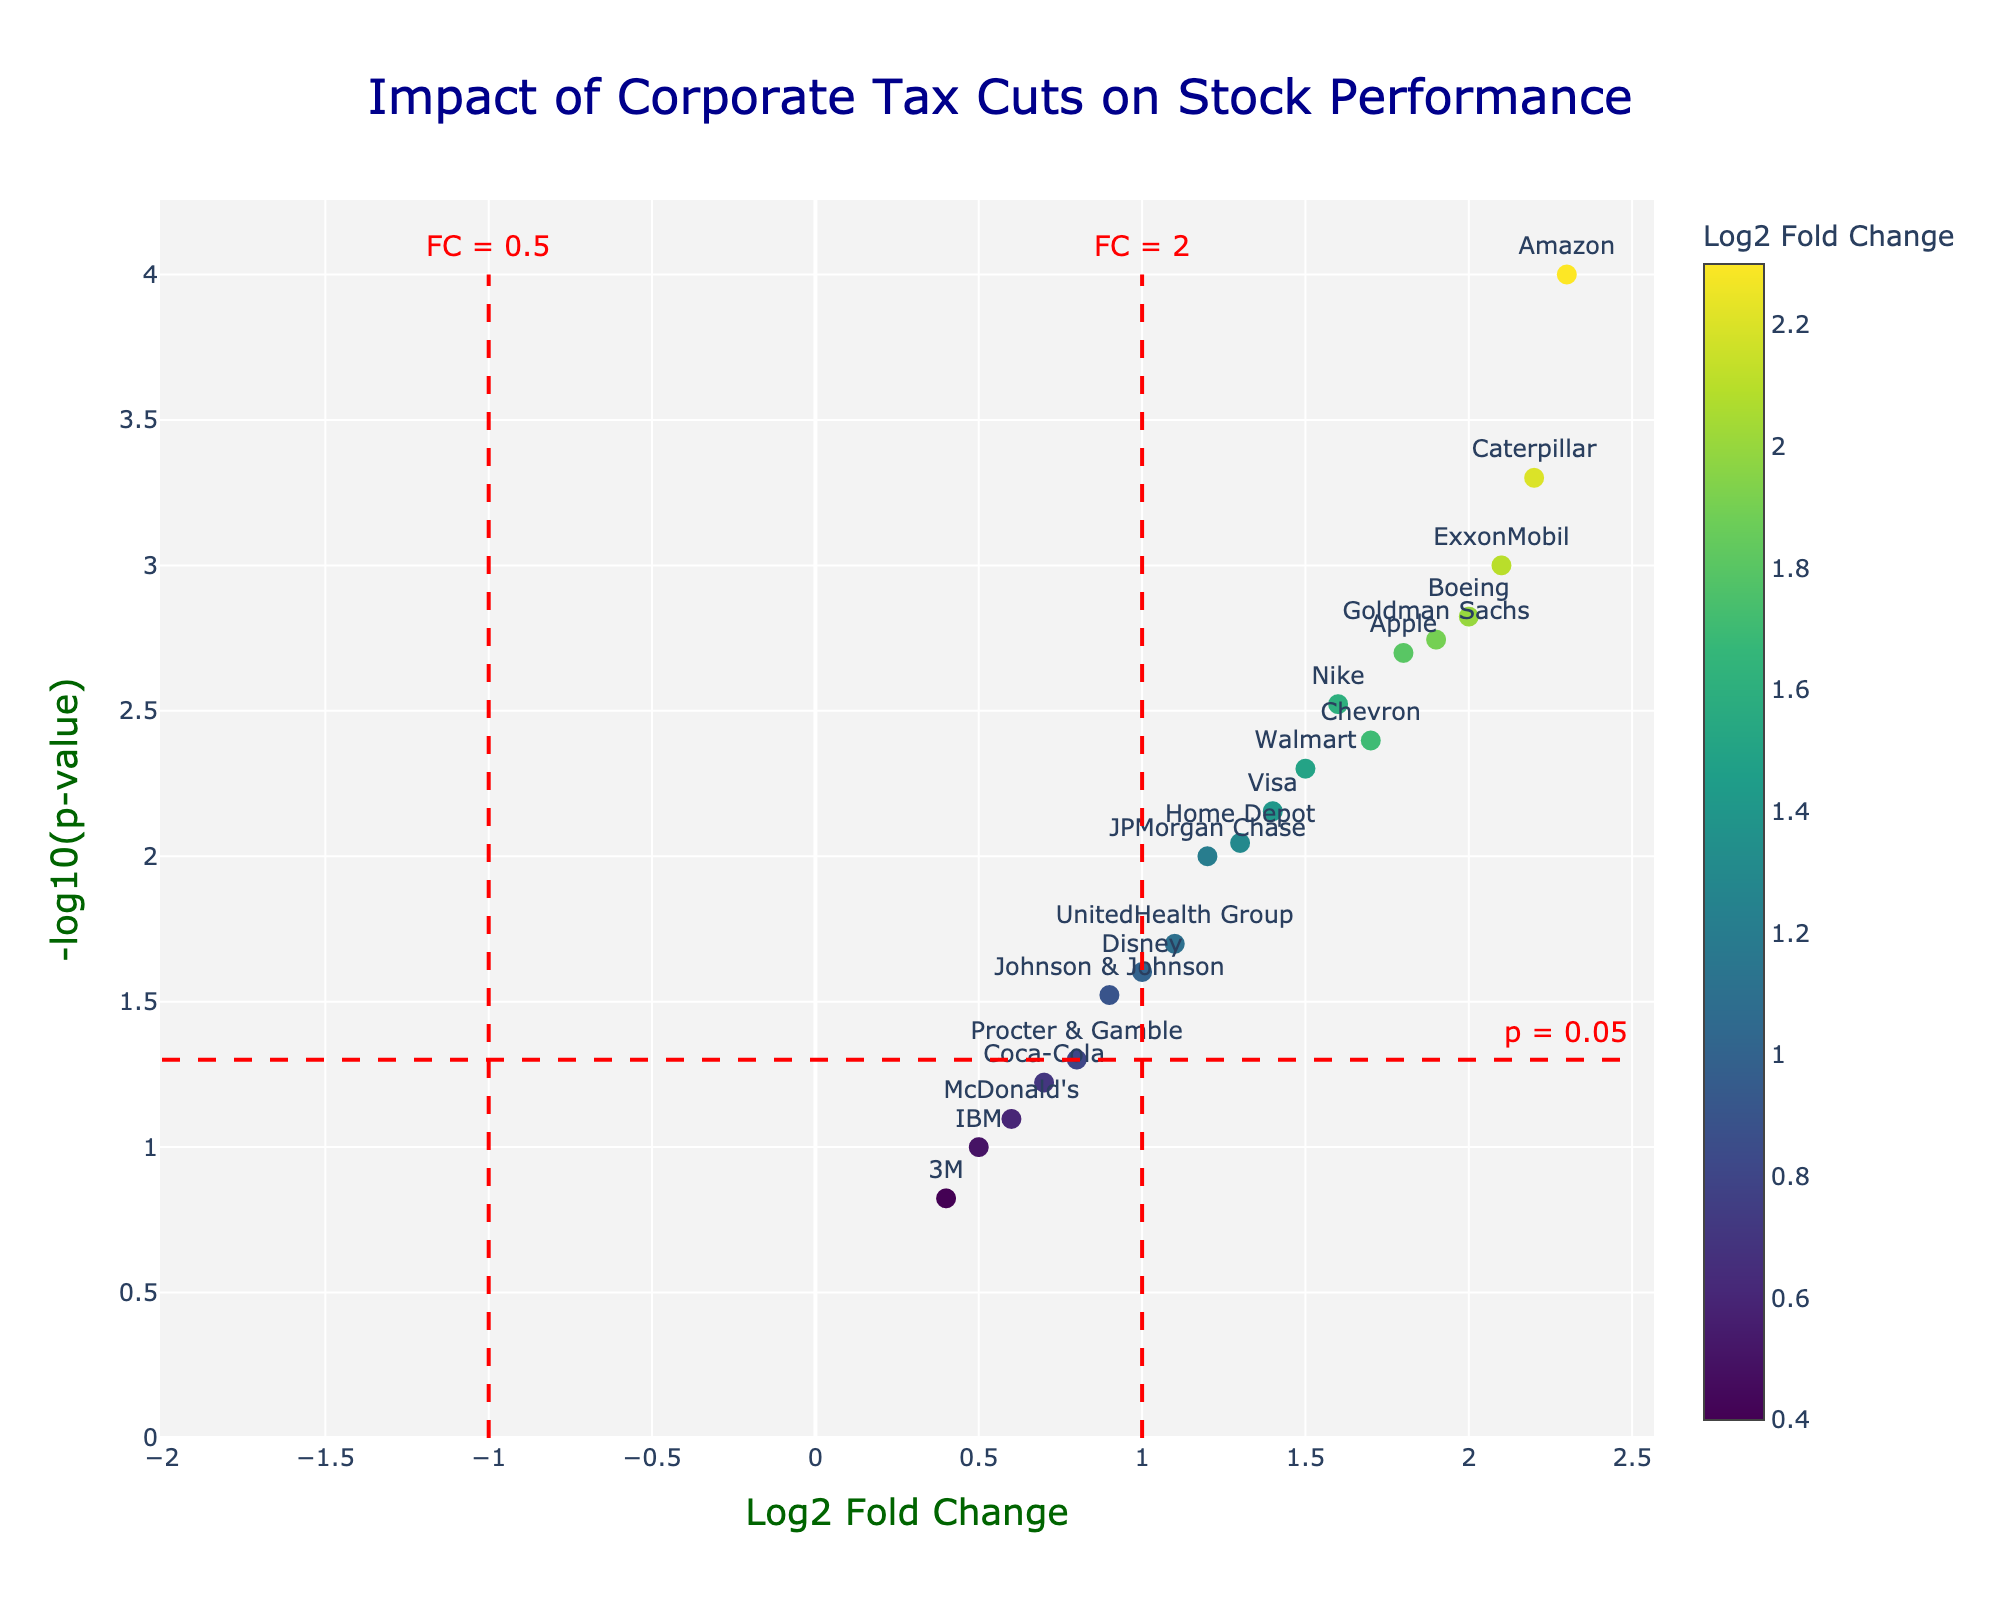What's the title of the plot? The title of the plot is displayed at the top center of the figure, and it is typically in a larger font size than the rest of the text on the plot.
Answer: Impact of Corporate Tax Cuts on Stock Performance Which company shows the highest -log10(p-value)? To determine the company with the highest -log10(p-value), look for the data point with the maximum y-axis value and identify the company labeled near that data point.
Answer: Amazon How many companies have a Log2 Fold Change greater than 1? Examine all data points and count the number of points that are positioned to the right of the x-axis value of 1.
Answer: 14 What is the Log2 Fold Change and p-value for ExxonMobil? Find the data point labeled "ExxonMobil" on the plot, then refer to the hover information or directly from the figure's annotation for the specific x and y values.
Answer: Log2 FC: 2.1, p-value: 0.001 Which companies have Log2 Fold Change values between 1 and 2 and a -log10(p-value) greater than 2? Identify data points between x-axis values of 1 and 2 and y-axis values greater than 2, then check the labels of these points.
Answer: Chevron, Apple, Boeing, Nike, Goldman Sachs Compare the -log10(p-value) of Walmart and JPMorgan Chase. Which one is greater? Locate the data points for both Walmart and JPMorgan Chase on the plot, then compare their y-axis values.
Answer: Walmart How does Johnson & Johnson’s p-value compare with that of McDonald’s? Convert -log10(p-value) back to p-value for both companies and compare: Johnson & Johnson (-log10(p) ≈ 1.52 ≈ p = 0.03), McDonald’s (-log10(p) ≈ 1.10 ≈ p = 0.08).
Answer: Johnson & Johnson has a smaller p-value Which company shows the smallest Log2 Fold Change, and what is its -log10(p-value)? Find the data point with the minimum x-axis value (leftmost point) and identify the corresponding y-axis value.
Answer: 3M, 0.4 How many companies had a p-value less than 0.05? Companies with -log10(p-value) greater than 1.3 have p-values less than 0.05; count these data points on the plot.
Answer: 11 What is the color scale used in the plot, and what does it represent? Observe the color of the data points and the color bar on the side of the plot; the color scale varies along the Log2 Fold Change values.
Answer: Viridis scale representing Log2 Fold Change 